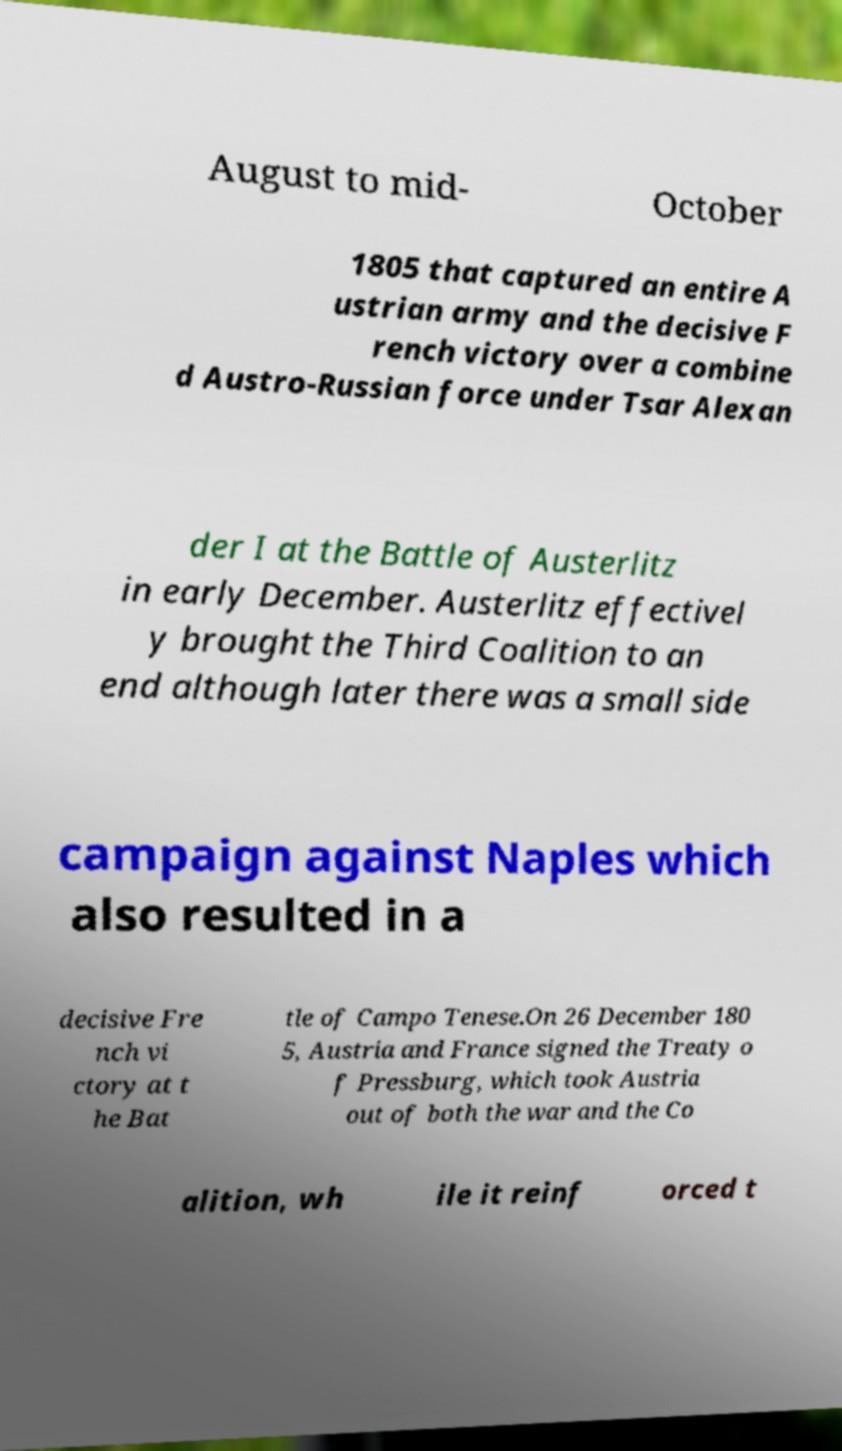Could you extract and type out the text from this image? August to mid- October 1805 that captured an entire A ustrian army and the decisive F rench victory over a combine d Austro-Russian force under Tsar Alexan der I at the Battle of Austerlitz in early December. Austerlitz effectivel y brought the Third Coalition to an end although later there was a small side campaign against Naples which also resulted in a decisive Fre nch vi ctory at t he Bat tle of Campo Tenese.On 26 December 180 5, Austria and France signed the Treaty o f Pressburg, which took Austria out of both the war and the Co alition, wh ile it reinf orced t 